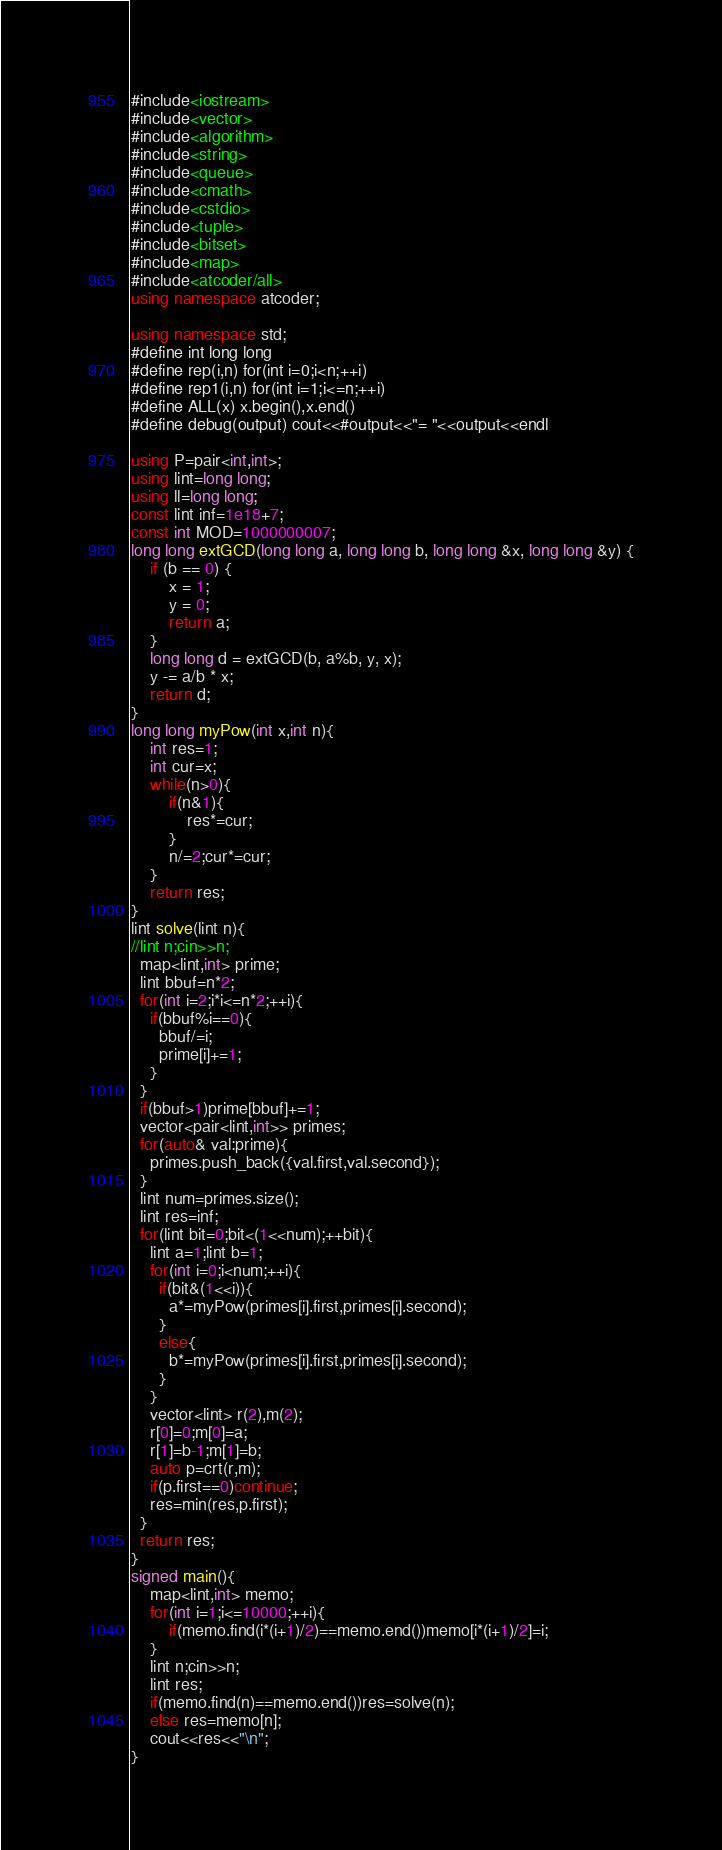<code> <loc_0><loc_0><loc_500><loc_500><_C++_>#include<iostream>
#include<vector>
#include<algorithm>
#include<string>
#include<queue>
#include<cmath>
#include<cstdio>
#include<tuple>
#include<bitset>
#include<map>
#include<atcoder/all>
using namespace atcoder;

using namespace std;
#define int long long
#define rep(i,n) for(int i=0;i<n;++i)
#define rep1(i,n) for(int i=1;i<=n;++i)
#define ALL(x) x.begin(),x.end()
#define debug(output) cout<<#output<<"= "<<output<<endl

using P=pair<int,int>;
using lint=long long;
using ll=long long;
const lint inf=1e18+7;
const int MOD=1000000007;
long long extGCD(long long a, long long b, long long &x, long long &y) {
    if (b == 0) {
        x = 1;
        y = 0;
        return a;
    }
    long long d = extGCD(b, a%b, y, x);
    y -= a/b * x;
    return d;
}
long long myPow(int x,int n){
    int res=1;
    int cur=x;
    while(n>0){
        if(n&1){
            res*=cur;
        }
        n/=2;cur*=cur;
    }
    return res;
}
lint solve(lint n){
//lint n;cin>>n;
  map<lint,int> prime;
  lint bbuf=n*2;
  for(int i=2;i*i<=n*2;++i){
    if(bbuf%i==0){
      bbuf/=i;
      prime[i]+=1;
    }
  }
  if(bbuf>1)prime[bbuf]+=1;
  vector<pair<lint,int>> primes;
  for(auto& val:prime){
    primes.push_back({val.first,val.second});
  }
  lint num=primes.size();
  lint res=inf;
  for(lint bit=0;bit<(1<<num);++bit){
    lint a=1;lint b=1;
    for(int i=0;i<num;++i){
      if(bit&(1<<i)){
        a*=myPow(primes[i].first,primes[i].second);
      }
      else{
        b*=myPow(primes[i].first,primes[i].second);
      }
    }
    vector<lint> r(2),m(2);
    r[0]=0;m[0]=a;
    r[1]=b-1;m[1]=b;
    auto p=crt(r,m);
    if(p.first==0)continue;
    res=min(res,p.first);
  }
  return res;
}
signed main(){
    map<lint,int> memo;
    for(int i=1;i<=10000;++i){
        if(memo.find(i*(i+1)/2)==memo.end())memo[i*(i+1)/2]=i;
    }
    lint n;cin>>n;
    lint res;
    if(memo.find(n)==memo.end())res=solve(n);
    else res=memo[n];
    cout<<res<<"\n";
}
</code> 